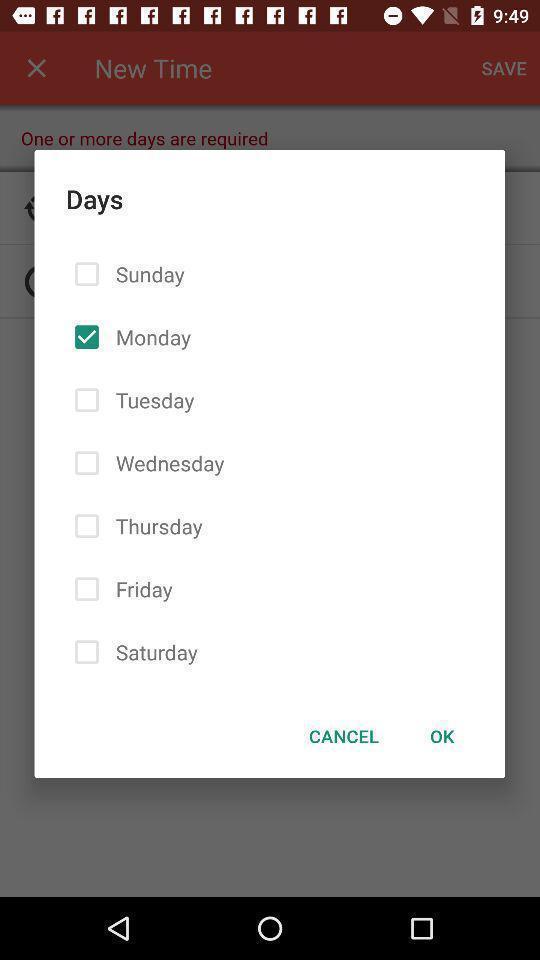Summarize the main components in this picture. Popup of days list to select in the application. 